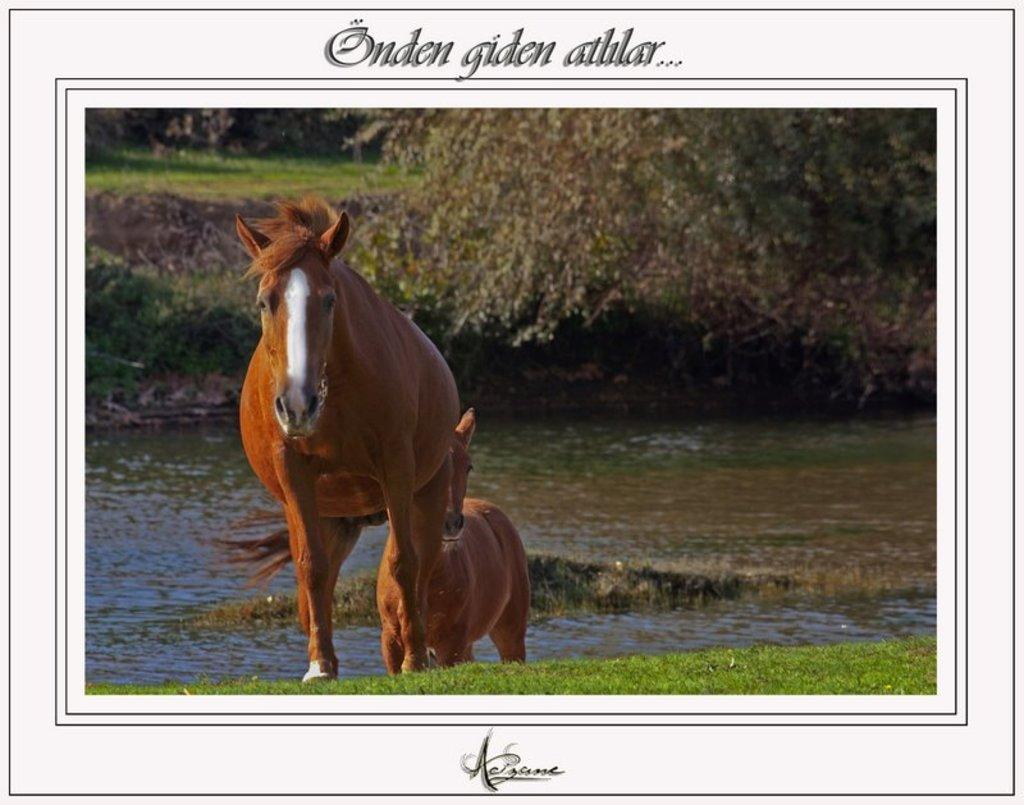What is the main subject of the poster in the image? The poster contains images of horses, water, grass, and trees. What type of environment is depicted in the poster? The poster depicts a natural environment with water, grass, and trees. Where is the text located on the poster? There is text at the top and bottom of the image. What type of toys can be seen in the image? There are no toys present in the image; it features a poster with images of horses, water, grass, and trees. What is the topic of the argument taking place in the image? There is no argument present in the image; it features a poster with images of horses, water, grass, and trees. 